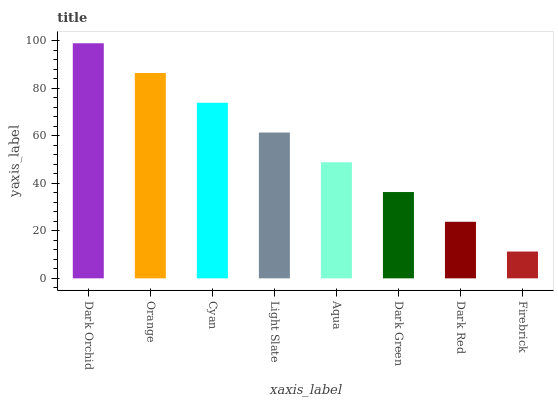Is Firebrick the minimum?
Answer yes or no. Yes. Is Dark Orchid the maximum?
Answer yes or no. Yes. Is Orange the minimum?
Answer yes or no. No. Is Orange the maximum?
Answer yes or no. No. Is Dark Orchid greater than Orange?
Answer yes or no. Yes. Is Orange less than Dark Orchid?
Answer yes or no. Yes. Is Orange greater than Dark Orchid?
Answer yes or no. No. Is Dark Orchid less than Orange?
Answer yes or no. No. Is Light Slate the high median?
Answer yes or no. Yes. Is Aqua the low median?
Answer yes or no. Yes. Is Dark Orchid the high median?
Answer yes or no. No. Is Light Slate the low median?
Answer yes or no. No. 